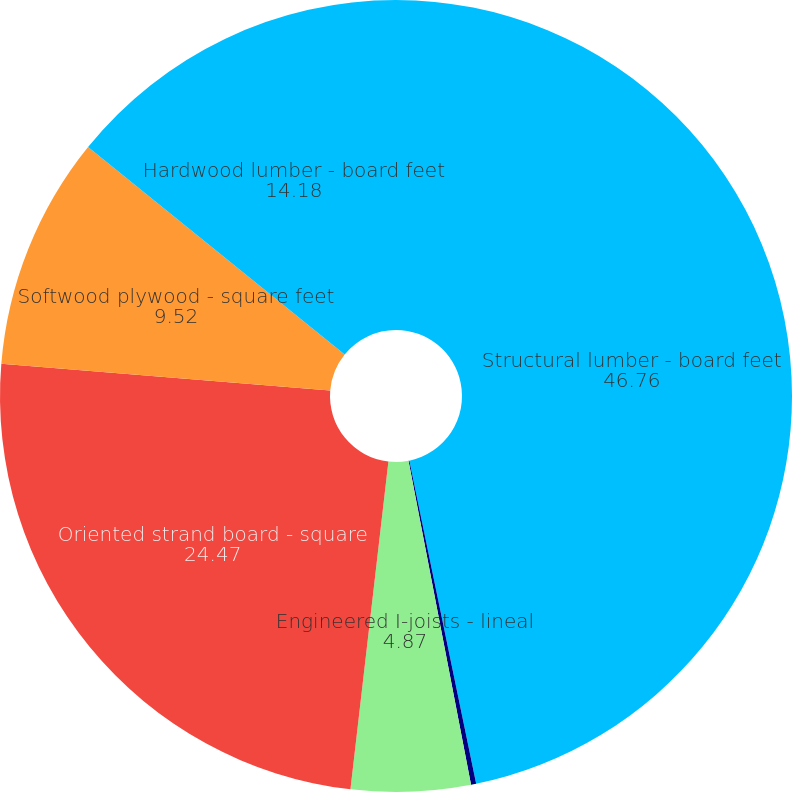Convert chart to OTSL. <chart><loc_0><loc_0><loc_500><loc_500><pie_chart><fcel>Structural lumber - board feet<fcel>Engineered solid section -<fcel>Engineered I-joists - lineal<fcel>Oriented strand board - square<fcel>Softwood plywood - square feet<fcel>Hardwood lumber - board feet<nl><fcel>46.76%<fcel>0.21%<fcel>4.87%<fcel>24.47%<fcel>9.52%<fcel>14.18%<nl></chart> 